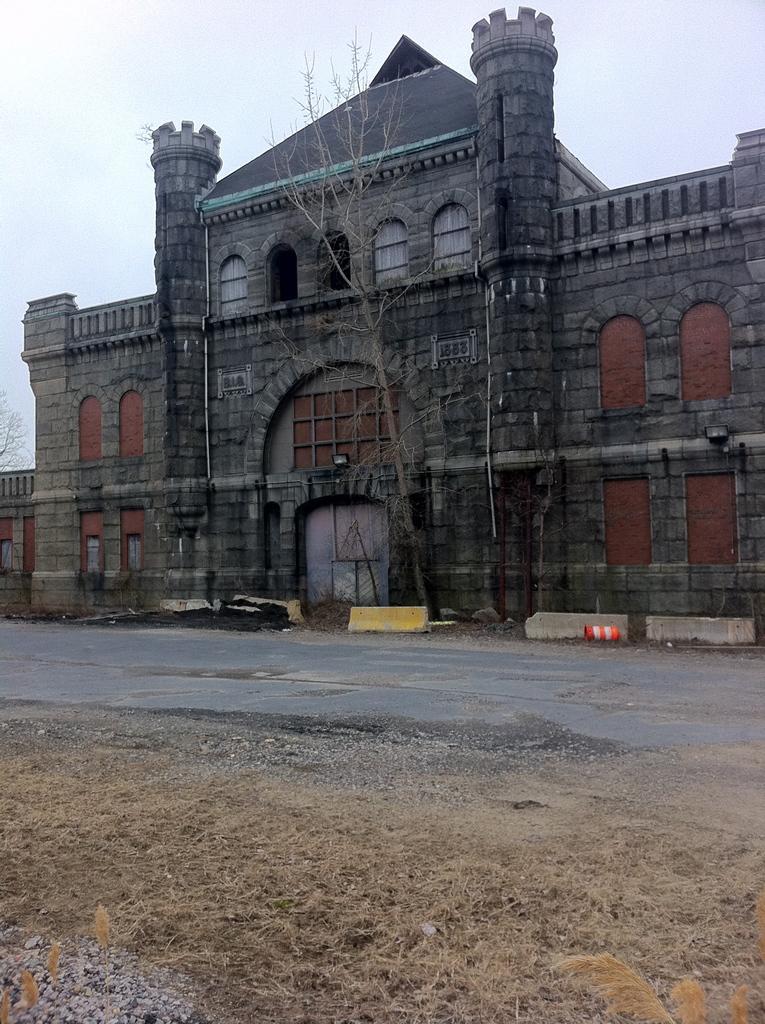How would you summarize this image in a sentence or two? In this picture we can see a building and an arch on the building. We can see few objects on the ground. There is some grass and few stones on the ground. There is a tree in the background. 